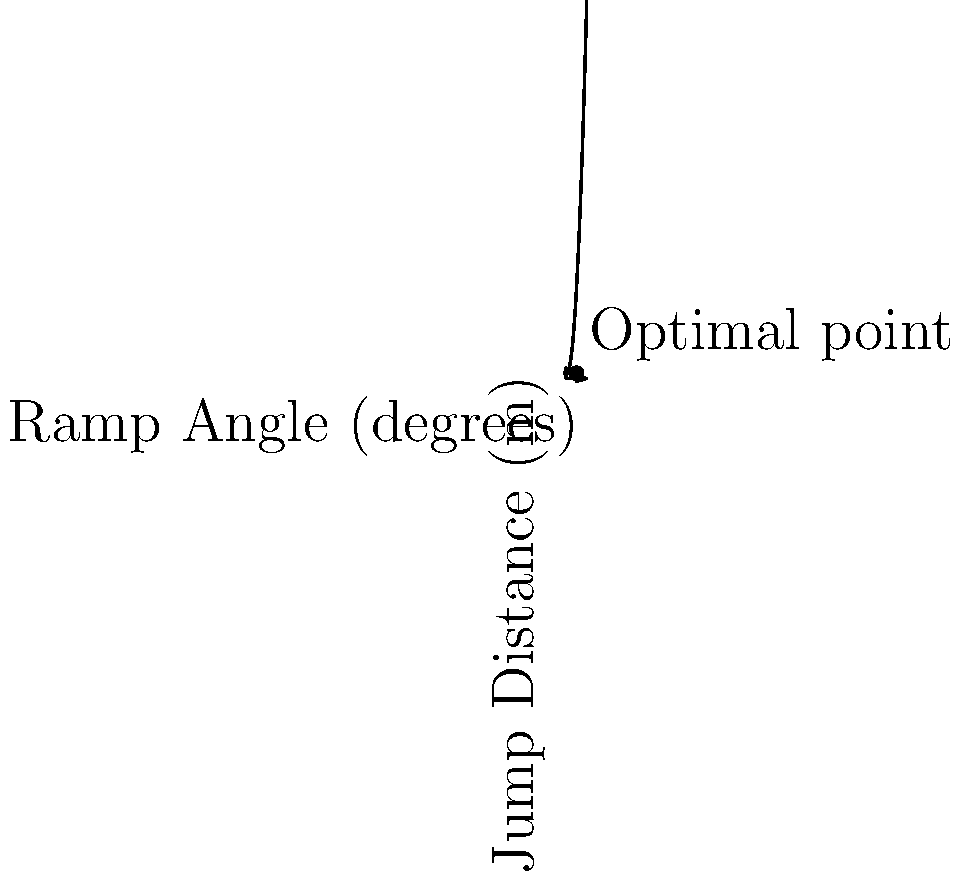Given the graph showing the relationship between BMX ramp angles and jump distances, what is the optimal ramp angle for achieving the maximum jump distance? To find the optimal ramp angle for maximum jump distance, we need to follow these steps:

1. Observe the graph: The curve represents the relationship between ramp angle (x-axis) and jump distance (y-axis).

2. Identify the vertex: The highest point on the curve represents the maximum jump distance.

3. Locate the x-coordinate: The x-coordinate of the vertex corresponds to the optimal ramp angle.

4. Read the value: From the graph, we can see that the vertex occurs at approximately 20 degrees.

5. Interpret the result: This means that a ramp angle of 20 degrees will result in the maximum jump distance for the given BMX setup.

6. Consider practical implications: As a BMX cyclist, you would want to adjust your ramp to this angle for competition jumps to achieve the best performance.

The graph shows a parabolic relationship, which is typical for projectile motion problems. The optimal angle balances the trade-off between initial velocity and time in the air, resulting in the maximum distance traveled.
Answer: 20 degrees 